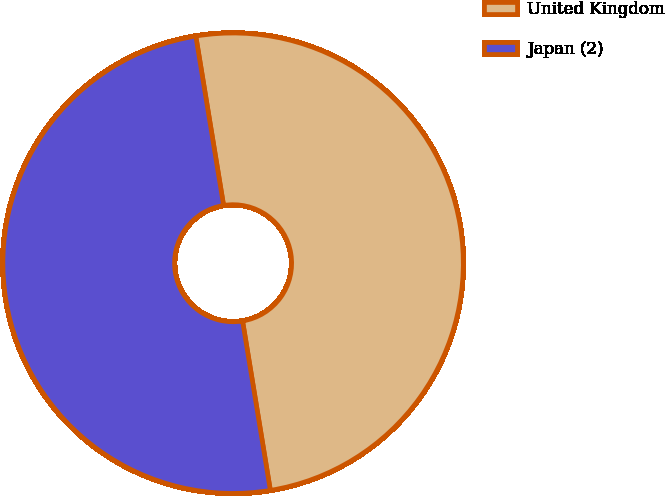Convert chart to OTSL. <chart><loc_0><loc_0><loc_500><loc_500><pie_chart><fcel>United Kingdom<fcel>Japan (2)<nl><fcel>50.0%<fcel>50.0%<nl></chart> 